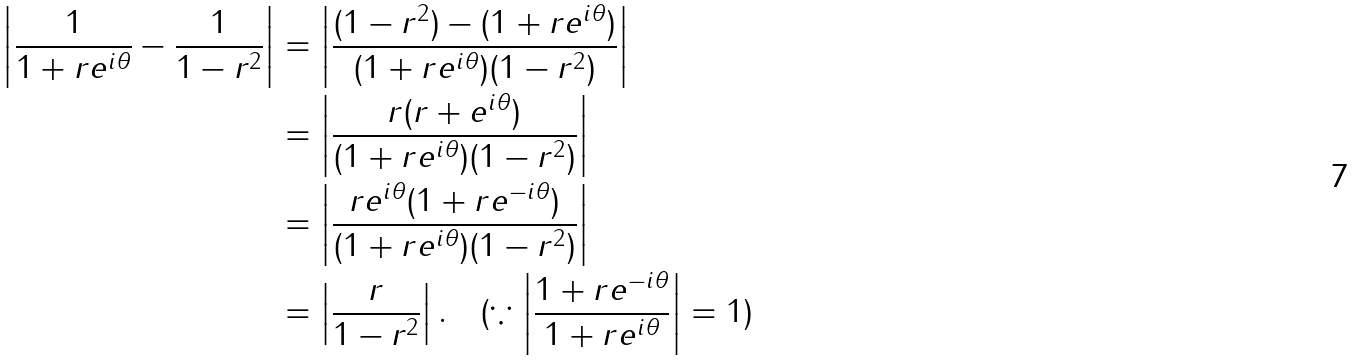Convert formula to latex. <formula><loc_0><loc_0><loc_500><loc_500>\left | \frac { 1 } { 1 + r e ^ { i \theta } } - \frac { 1 } { 1 - r ^ { 2 } } \right | & = \left | \frac { ( 1 - r ^ { 2 } ) - ( 1 + r e ^ { i \theta } ) } { ( 1 + r e ^ { i \theta } ) ( 1 - r ^ { 2 } ) } \right | \\ & = \left | \frac { r ( r + e ^ { i \theta } ) } { ( 1 + r e ^ { i \theta } ) ( 1 - r ^ { 2 } ) } \right | \\ & = \left | \frac { r e ^ { i \theta } ( 1 + r e ^ { - i \theta } ) } { ( 1 + r e ^ { i \theta } ) ( 1 - r ^ { 2 } ) } \right | \\ & = \left | \frac { r } { 1 - r ^ { 2 } } \right | . \quad ( \because \left | \frac { 1 + r e ^ { - i \theta } } { 1 + r e ^ { i \theta } } \right | = 1 )</formula> 